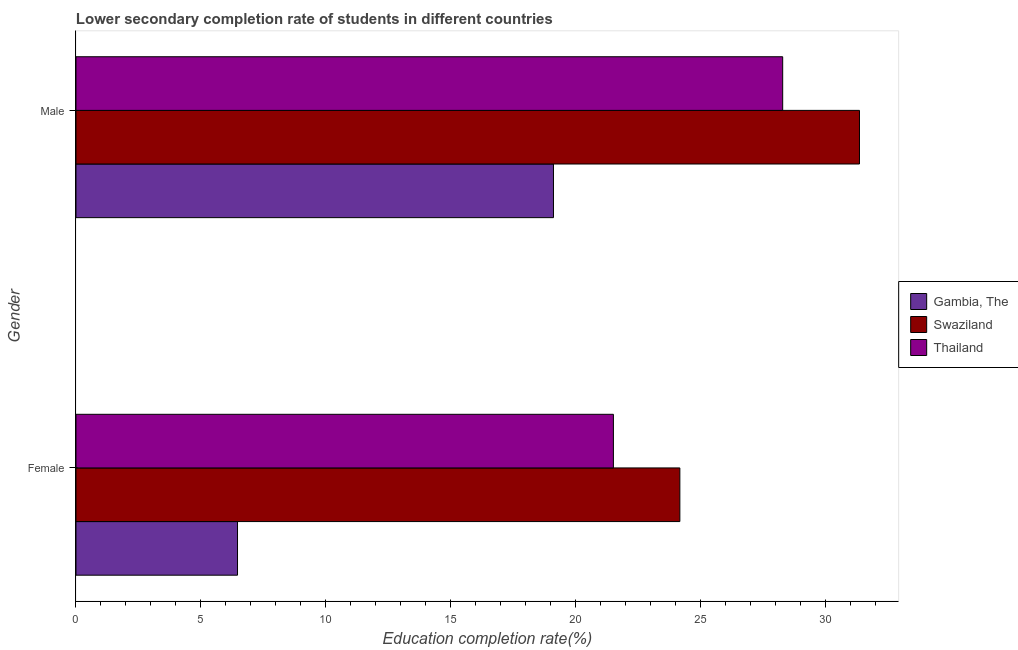Are the number of bars per tick equal to the number of legend labels?
Make the answer very short. Yes. Are the number of bars on each tick of the Y-axis equal?
Provide a succinct answer. Yes. How many bars are there on the 1st tick from the top?
Offer a terse response. 3. What is the label of the 2nd group of bars from the top?
Give a very brief answer. Female. What is the education completion rate of female students in Swaziland?
Your answer should be very brief. 24.17. Across all countries, what is the maximum education completion rate of female students?
Your answer should be compact. 24.17. Across all countries, what is the minimum education completion rate of female students?
Make the answer very short. 6.47. In which country was the education completion rate of female students maximum?
Ensure brevity in your answer.  Swaziland. In which country was the education completion rate of female students minimum?
Provide a succinct answer. Gambia, The. What is the total education completion rate of male students in the graph?
Your answer should be compact. 78.77. What is the difference between the education completion rate of male students in Thailand and that in Gambia, The?
Ensure brevity in your answer.  9.18. What is the difference between the education completion rate of female students in Gambia, The and the education completion rate of male students in Thailand?
Provide a short and direct response. -21.82. What is the average education completion rate of female students per country?
Offer a terse response. 17.38. What is the difference between the education completion rate of female students and education completion rate of male students in Thailand?
Provide a succinct answer. -6.78. What is the ratio of the education completion rate of female students in Gambia, The to that in Thailand?
Your answer should be compact. 0.3. What does the 1st bar from the top in Male represents?
Provide a succinct answer. Thailand. What does the 1st bar from the bottom in Male represents?
Ensure brevity in your answer.  Gambia, The. Are the values on the major ticks of X-axis written in scientific E-notation?
Offer a terse response. No. Does the graph contain grids?
Provide a short and direct response. No. What is the title of the graph?
Give a very brief answer. Lower secondary completion rate of students in different countries. Does "Korea (Republic)" appear as one of the legend labels in the graph?
Ensure brevity in your answer.  No. What is the label or title of the X-axis?
Your response must be concise. Education completion rate(%). What is the label or title of the Y-axis?
Your answer should be very brief. Gender. What is the Education completion rate(%) of Gambia, The in Female?
Provide a succinct answer. 6.47. What is the Education completion rate(%) in Swaziland in Female?
Ensure brevity in your answer.  24.17. What is the Education completion rate(%) in Thailand in Female?
Your answer should be compact. 21.51. What is the Education completion rate(%) of Gambia, The in Male?
Make the answer very short. 19.11. What is the Education completion rate(%) of Swaziland in Male?
Give a very brief answer. 31.36. What is the Education completion rate(%) of Thailand in Male?
Your answer should be compact. 28.29. Across all Gender, what is the maximum Education completion rate(%) in Gambia, The?
Give a very brief answer. 19.11. Across all Gender, what is the maximum Education completion rate(%) of Swaziland?
Your response must be concise. 31.36. Across all Gender, what is the maximum Education completion rate(%) of Thailand?
Your answer should be very brief. 28.29. Across all Gender, what is the minimum Education completion rate(%) of Gambia, The?
Your answer should be compact. 6.47. Across all Gender, what is the minimum Education completion rate(%) of Swaziland?
Keep it short and to the point. 24.17. Across all Gender, what is the minimum Education completion rate(%) in Thailand?
Your response must be concise. 21.51. What is the total Education completion rate(%) of Gambia, The in the graph?
Your answer should be compact. 25.58. What is the total Education completion rate(%) in Swaziland in the graph?
Offer a terse response. 55.54. What is the total Education completion rate(%) of Thailand in the graph?
Provide a succinct answer. 49.8. What is the difference between the Education completion rate(%) of Gambia, The in Female and that in Male?
Keep it short and to the point. -12.65. What is the difference between the Education completion rate(%) of Swaziland in Female and that in Male?
Your answer should be very brief. -7.19. What is the difference between the Education completion rate(%) of Thailand in Female and that in Male?
Keep it short and to the point. -6.78. What is the difference between the Education completion rate(%) in Gambia, The in Female and the Education completion rate(%) in Swaziland in Male?
Provide a short and direct response. -24.9. What is the difference between the Education completion rate(%) in Gambia, The in Female and the Education completion rate(%) in Thailand in Male?
Make the answer very short. -21.82. What is the difference between the Education completion rate(%) in Swaziland in Female and the Education completion rate(%) in Thailand in Male?
Your response must be concise. -4.12. What is the average Education completion rate(%) of Gambia, The per Gender?
Make the answer very short. 12.79. What is the average Education completion rate(%) of Swaziland per Gender?
Your response must be concise. 27.77. What is the average Education completion rate(%) of Thailand per Gender?
Ensure brevity in your answer.  24.9. What is the difference between the Education completion rate(%) in Gambia, The and Education completion rate(%) in Swaziland in Female?
Offer a very short reply. -17.71. What is the difference between the Education completion rate(%) in Gambia, The and Education completion rate(%) in Thailand in Female?
Make the answer very short. -15.05. What is the difference between the Education completion rate(%) of Swaziland and Education completion rate(%) of Thailand in Female?
Give a very brief answer. 2.66. What is the difference between the Education completion rate(%) of Gambia, The and Education completion rate(%) of Swaziland in Male?
Make the answer very short. -12.25. What is the difference between the Education completion rate(%) in Gambia, The and Education completion rate(%) in Thailand in Male?
Make the answer very short. -9.18. What is the difference between the Education completion rate(%) of Swaziland and Education completion rate(%) of Thailand in Male?
Provide a short and direct response. 3.07. What is the ratio of the Education completion rate(%) in Gambia, The in Female to that in Male?
Keep it short and to the point. 0.34. What is the ratio of the Education completion rate(%) in Swaziland in Female to that in Male?
Offer a terse response. 0.77. What is the ratio of the Education completion rate(%) of Thailand in Female to that in Male?
Give a very brief answer. 0.76. What is the difference between the highest and the second highest Education completion rate(%) in Gambia, The?
Keep it short and to the point. 12.65. What is the difference between the highest and the second highest Education completion rate(%) in Swaziland?
Keep it short and to the point. 7.19. What is the difference between the highest and the second highest Education completion rate(%) of Thailand?
Ensure brevity in your answer.  6.78. What is the difference between the highest and the lowest Education completion rate(%) in Gambia, The?
Offer a terse response. 12.65. What is the difference between the highest and the lowest Education completion rate(%) of Swaziland?
Offer a very short reply. 7.19. What is the difference between the highest and the lowest Education completion rate(%) of Thailand?
Offer a terse response. 6.78. 